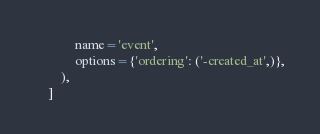Convert code to text. <code><loc_0><loc_0><loc_500><loc_500><_Python_>            name='event',
            options={'ordering': ('-created_at',)},
        ),
    ]
</code> 